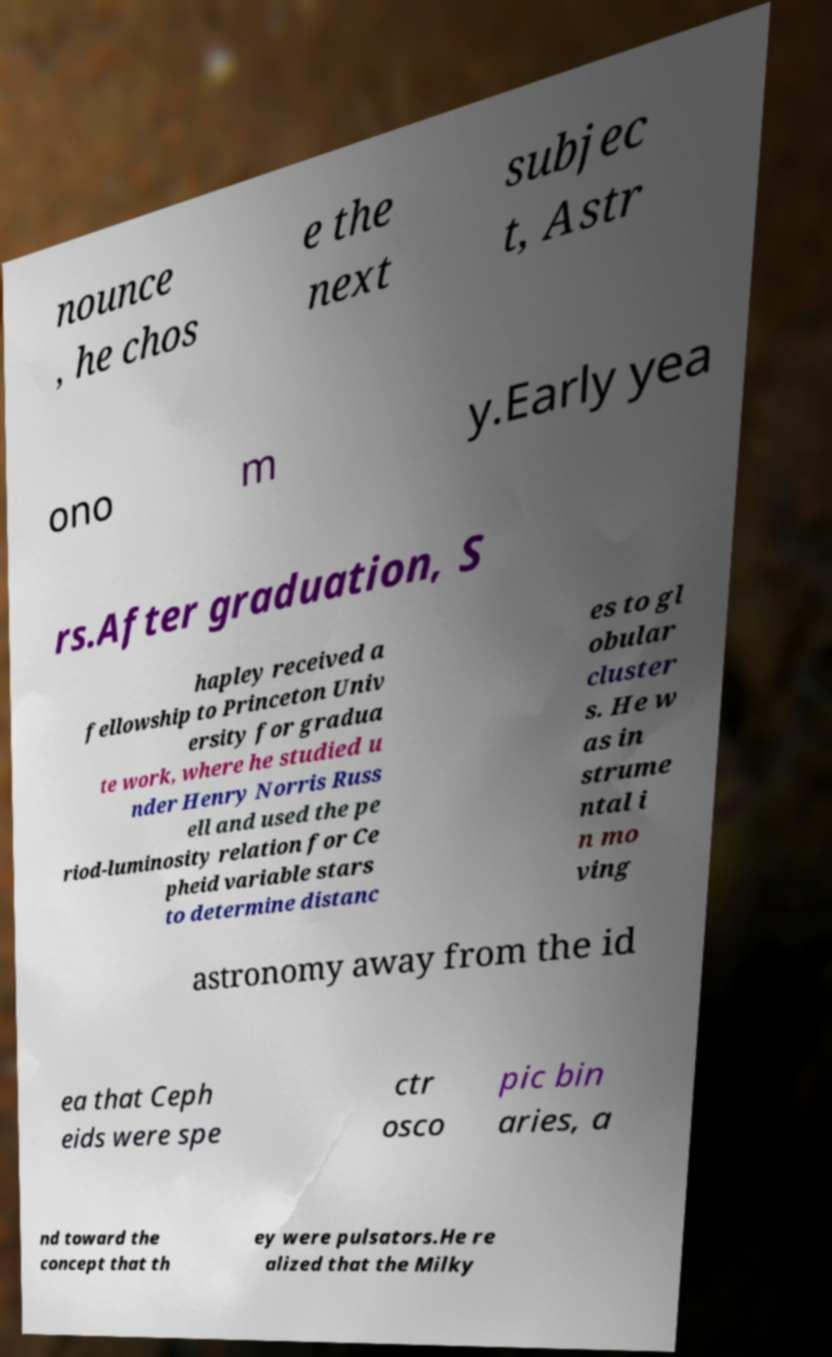I need the written content from this picture converted into text. Can you do that? nounce , he chos e the next subjec t, Astr ono m y.Early yea rs.After graduation, S hapley received a fellowship to Princeton Univ ersity for gradua te work, where he studied u nder Henry Norris Russ ell and used the pe riod-luminosity relation for Ce pheid variable stars to determine distanc es to gl obular cluster s. He w as in strume ntal i n mo ving astronomy away from the id ea that Ceph eids were spe ctr osco pic bin aries, a nd toward the concept that th ey were pulsators.He re alized that the Milky 